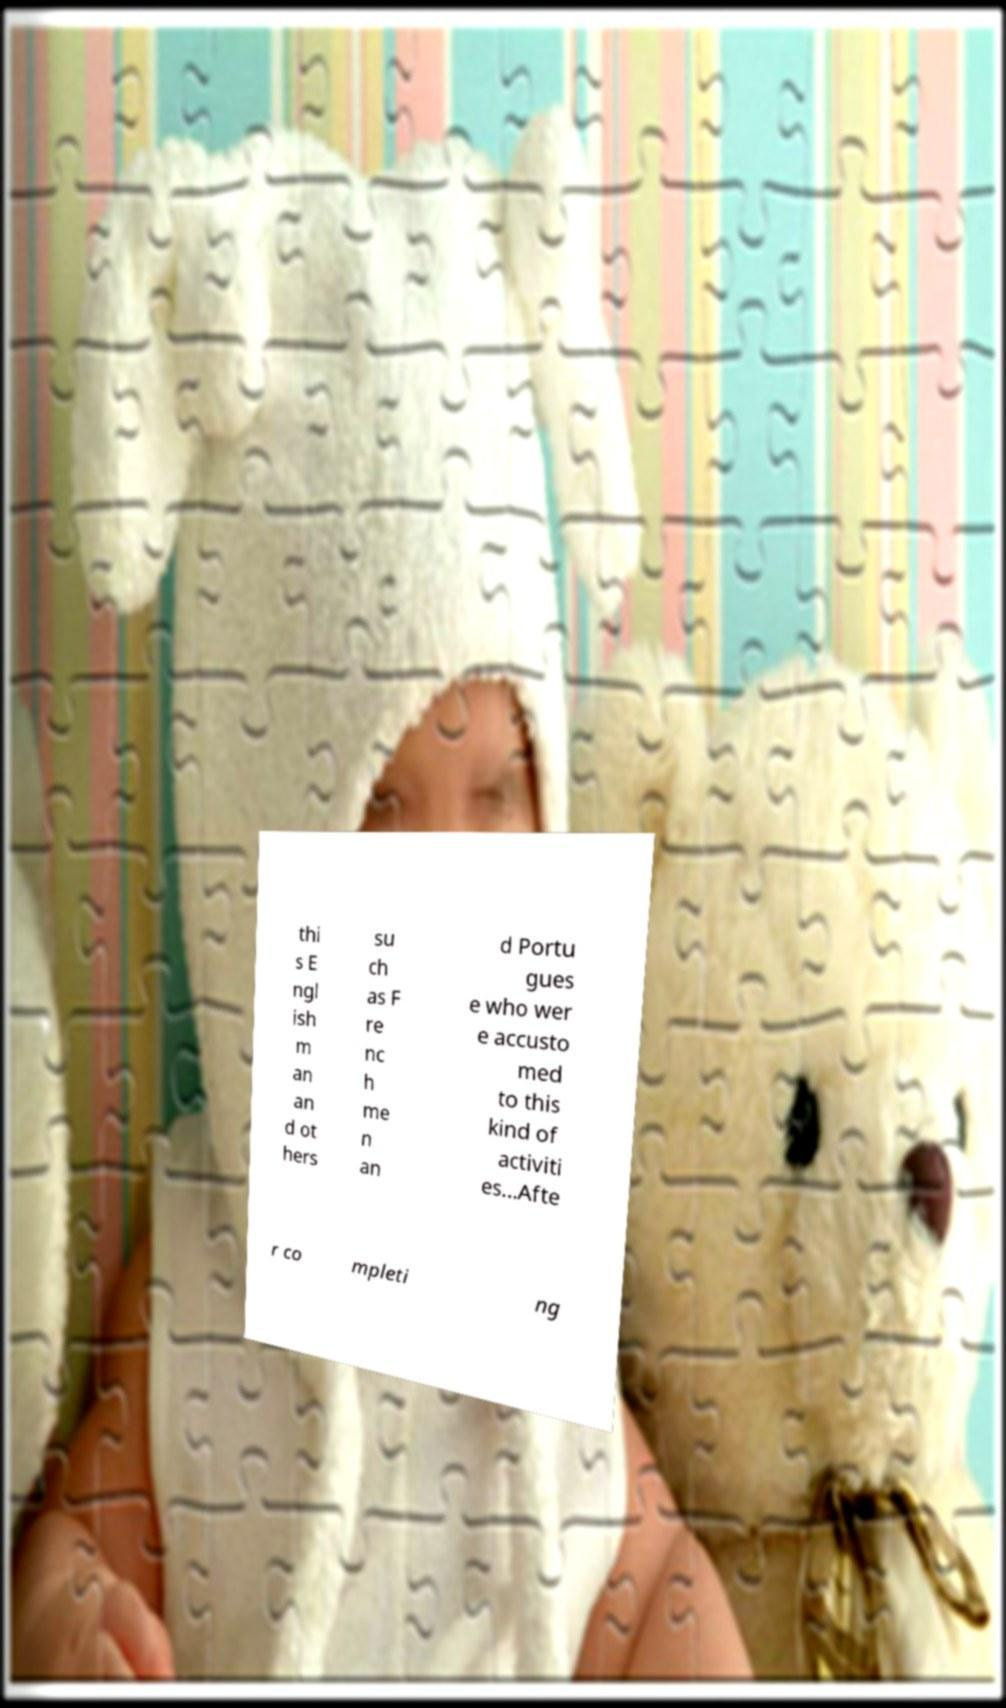What messages or text are displayed in this image? I need them in a readable, typed format. thi s E ngl ish m an an d ot hers su ch as F re nc h me n an d Portu gues e who wer e accusto med to this kind of activiti es...Afte r co mpleti ng 